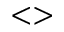Convert formula to latex. <formula><loc_0><loc_0><loc_500><loc_500>< ></formula> 